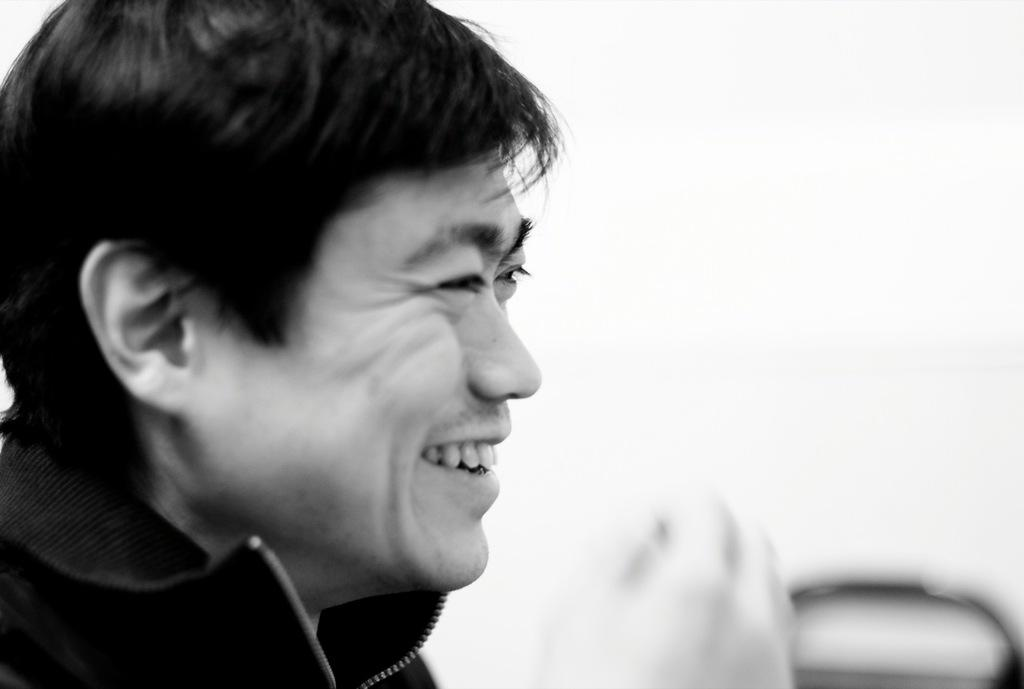What is the color scheme of the image? The image is black and white. What is the main subject of the image? There is a man in the image. What type of church can be seen in the background of the image? There is no church present in the image, as it is black and white and only features a man. How does the man in the image grip the object he is holding? There is no object visible in the man's hand in the image, so it is not possible to determine how he grips it. 